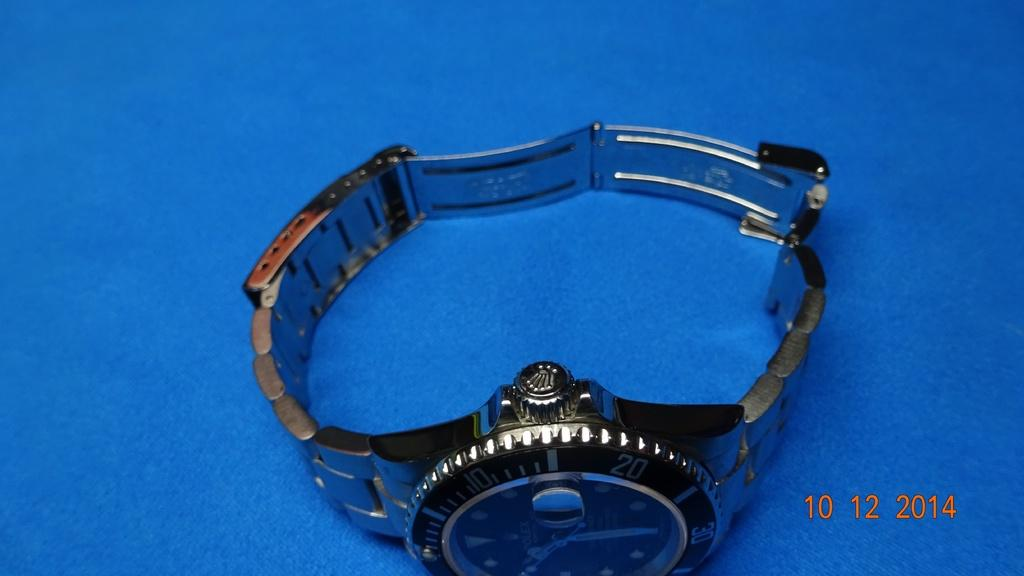<image>
Create a compact narrative representing the image presented. A wristwatch on a blue background has a dial that goes from 10, 20, to 30 and so on. 